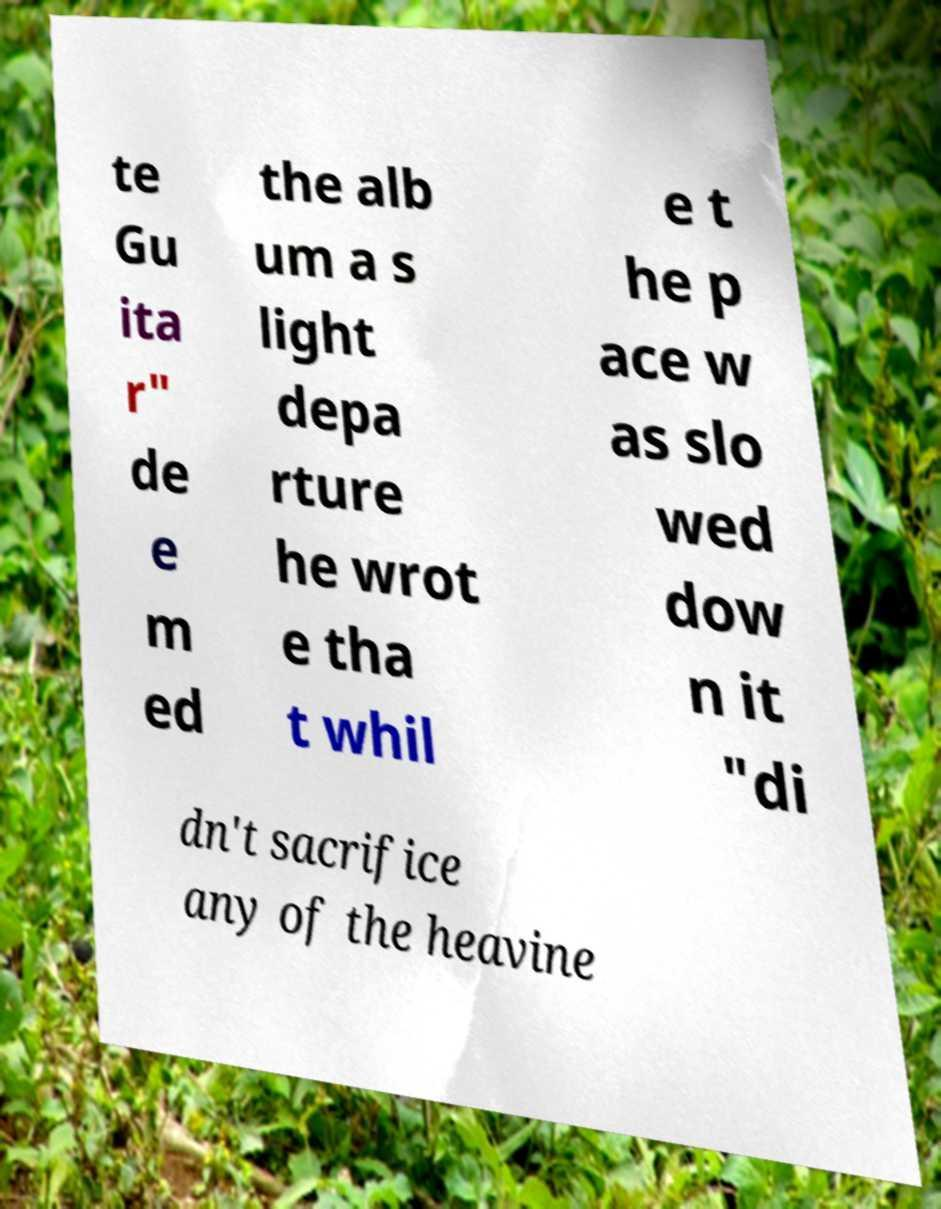What messages or text are displayed in this image? I need them in a readable, typed format. te Gu ita r" de e m ed the alb um a s light depa rture he wrot e tha t whil e t he p ace w as slo wed dow n it "di dn't sacrifice any of the heavine 